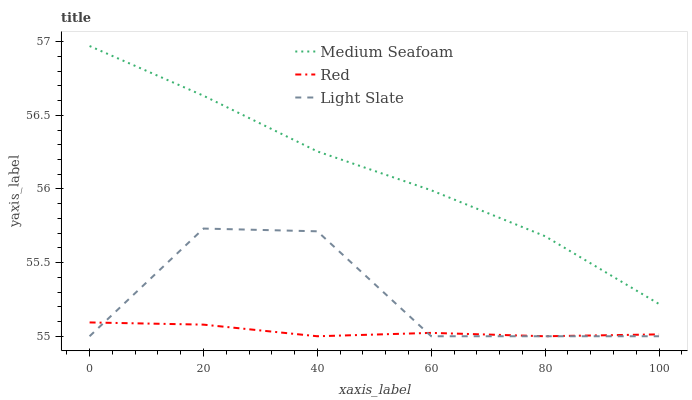Does Medium Seafoam have the minimum area under the curve?
Answer yes or no. No. Does Red have the maximum area under the curve?
Answer yes or no. No. Is Medium Seafoam the smoothest?
Answer yes or no. No. Is Medium Seafoam the roughest?
Answer yes or no. No. Does Medium Seafoam have the lowest value?
Answer yes or no. No. Does Red have the highest value?
Answer yes or no. No. Is Red less than Medium Seafoam?
Answer yes or no. Yes. Is Medium Seafoam greater than Light Slate?
Answer yes or no. Yes. Does Red intersect Medium Seafoam?
Answer yes or no. No. 